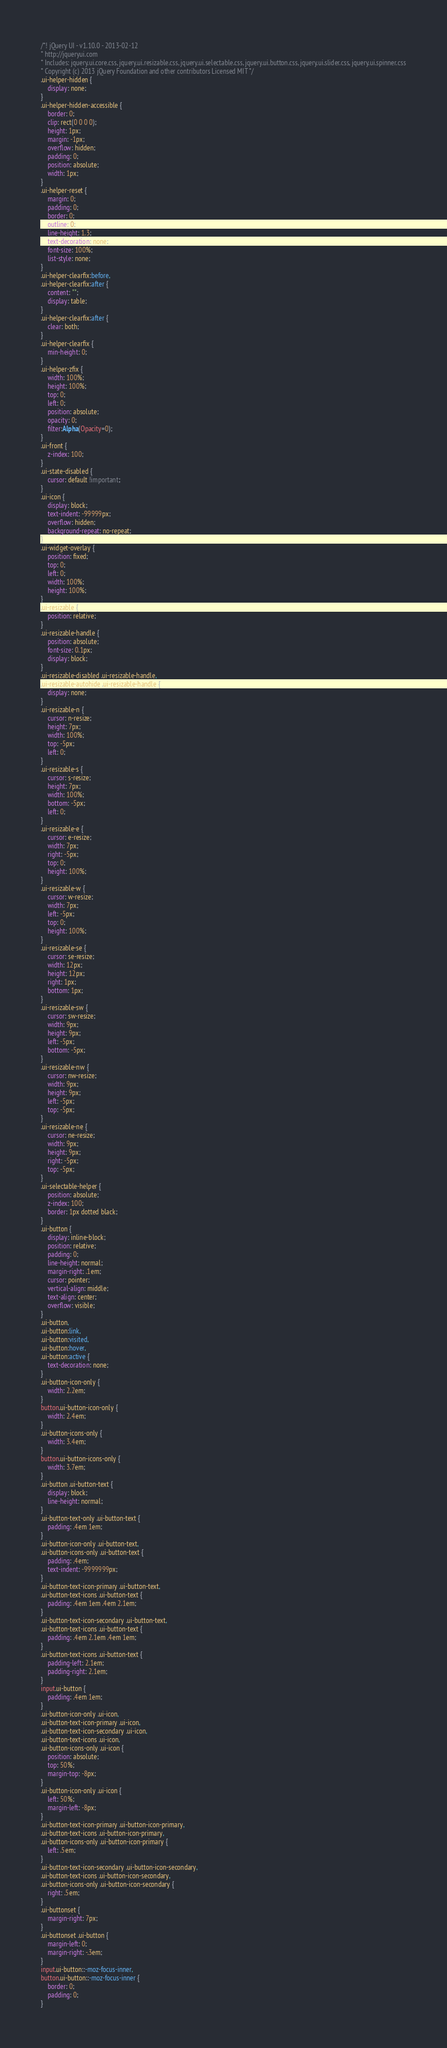<code> <loc_0><loc_0><loc_500><loc_500><_CSS_>/*! jQuery UI - v1.10.0 - 2013-02-12
* http://jqueryui.com
* Includes: jquery.ui.core.css, jquery.ui.resizable.css, jquery.ui.selectable.css, jquery.ui.button.css, jquery.ui.slider.css, jquery.ui.spinner.css
* Copyright (c) 2013 jQuery Foundation and other contributors Licensed MIT */
.ui-helper-hidden {
	display: none;
}
.ui-helper-hidden-accessible {
	border: 0;
	clip: rect(0 0 0 0);
	height: 1px;
	margin: -1px;
	overflow: hidden;
	padding: 0;
	position: absolute;
	width: 1px;
}
.ui-helper-reset {
	margin: 0;
	padding: 0;
	border: 0;
	outline: 0;
	line-height: 1.3;
	text-decoration: none;
	font-size: 100%;
	list-style: none;
}
.ui-helper-clearfix:before,
.ui-helper-clearfix:after {
	content: "";
	display: table;
}
.ui-helper-clearfix:after {
	clear: both;
}
.ui-helper-clearfix {
	min-height: 0; 
}
.ui-helper-zfix {
	width: 100%;
	height: 100%;
	top: 0;
	left: 0;
	position: absolute;
	opacity: 0;
	filter:Alpha(Opacity=0);
}
.ui-front {
	z-index: 100;
}
.ui-state-disabled {
	cursor: default !important;
}
.ui-icon {
	display: block;
	text-indent: -99999px;
	overflow: hidden;
	background-repeat: no-repeat;
}
.ui-widget-overlay {
	position: fixed;
	top: 0;
	left: 0;
	width: 100%;
	height: 100%;
}
.ui-resizable {
	position: relative;
}
.ui-resizable-handle {
	position: absolute;
	font-size: 0.1px;
	display: block;
}
.ui-resizable-disabled .ui-resizable-handle,
.ui-resizable-autohide .ui-resizable-handle {
	display: none;
}
.ui-resizable-n {
	cursor: n-resize;
	height: 7px;
	width: 100%;
	top: -5px;
	left: 0;
}
.ui-resizable-s {
	cursor: s-resize;
	height: 7px;
	width: 100%;
	bottom: -5px;
	left: 0;
}
.ui-resizable-e {
	cursor: e-resize;
	width: 7px;
	right: -5px;
	top: 0;
	height: 100%;
}
.ui-resizable-w {
	cursor: w-resize;
	width: 7px;
	left: -5px;
	top: 0;
	height: 100%;
}
.ui-resizable-se {
	cursor: se-resize;
	width: 12px;
	height: 12px;
	right: 1px;
	bottom: 1px;
}
.ui-resizable-sw {
	cursor: sw-resize;
	width: 9px;
	height: 9px;
	left: -5px;
	bottom: -5px;
}
.ui-resizable-nw {
	cursor: nw-resize;
	width: 9px;
	height: 9px;
	left: -5px;
	top: -5px;
}
.ui-resizable-ne {
	cursor: ne-resize;
	width: 9px;
	height: 9px;
	right: -5px;
	top: -5px;
}
.ui-selectable-helper {
	position: absolute;
	z-index: 100;
	border: 1px dotted black;
}
.ui-button {
	display: inline-block;
	position: relative;
	padding: 0;
	line-height: normal;
	margin-right: .1em;
	cursor: pointer;
	vertical-align: middle;
	text-align: center;
	overflow: visible; 
}
.ui-button,
.ui-button:link,
.ui-button:visited,
.ui-button:hover,
.ui-button:active {
	text-decoration: none;
}
.ui-button-icon-only {
	width: 2.2em;
}
button.ui-button-icon-only {
	width: 2.4em;
}
.ui-button-icons-only {
	width: 3.4em;
}
button.ui-button-icons-only {
	width: 3.7em;
}
.ui-button .ui-button-text {
	display: block;
	line-height: normal;
}
.ui-button-text-only .ui-button-text {
	padding: .4em 1em;
}
.ui-button-icon-only .ui-button-text,
.ui-button-icons-only .ui-button-text {
	padding: .4em;
	text-indent: -9999999px;
}
.ui-button-text-icon-primary .ui-button-text,
.ui-button-text-icons .ui-button-text {
	padding: .4em 1em .4em 2.1em;
}
.ui-button-text-icon-secondary .ui-button-text,
.ui-button-text-icons .ui-button-text {
	padding: .4em 2.1em .4em 1em;
}
.ui-button-text-icons .ui-button-text {
	padding-left: 2.1em;
	padding-right: 2.1em;
}
input.ui-button {
	padding: .4em 1em;
}
.ui-button-icon-only .ui-icon,
.ui-button-text-icon-primary .ui-icon,
.ui-button-text-icon-secondary .ui-icon,
.ui-button-text-icons .ui-icon,
.ui-button-icons-only .ui-icon {
	position: absolute;
	top: 50%;
	margin-top: -8px;
}
.ui-button-icon-only .ui-icon {
	left: 50%;
	margin-left: -8px;
}
.ui-button-text-icon-primary .ui-button-icon-primary,
.ui-button-text-icons .ui-button-icon-primary,
.ui-button-icons-only .ui-button-icon-primary {
	left: .5em;
}
.ui-button-text-icon-secondary .ui-button-icon-secondary,
.ui-button-text-icons .ui-button-icon-secondary,
.ui-button-icons-only .ui-button-icon-secondary {
	right: .5em;
}
.ui-buttonset {
	margin-right: 7px;
}
.ui-buttonset .ui-button {
	margin-left: 0;
	margin-right: -.3em;
}
input.ui-button::-moz-focus-inner,
button.ui-button::-moz-focus-inner {
	border: 0;
	padding: 0;
}</code> 